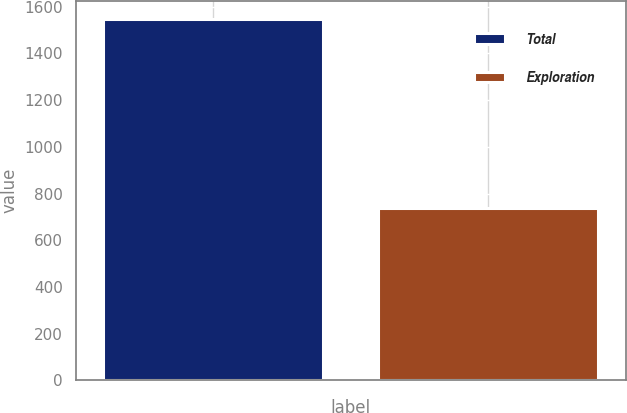Convert chart. <chart><loc_0><loc_0><loc_500><loc_500><bar_chart><fcel>Total<fcel>Exploration<nl><fcel>1548<fcel>738<nl></chart> 